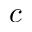Convert formula to latex. <formula><loc_0><loc_0><loc_500><loc_500>c</formula> 